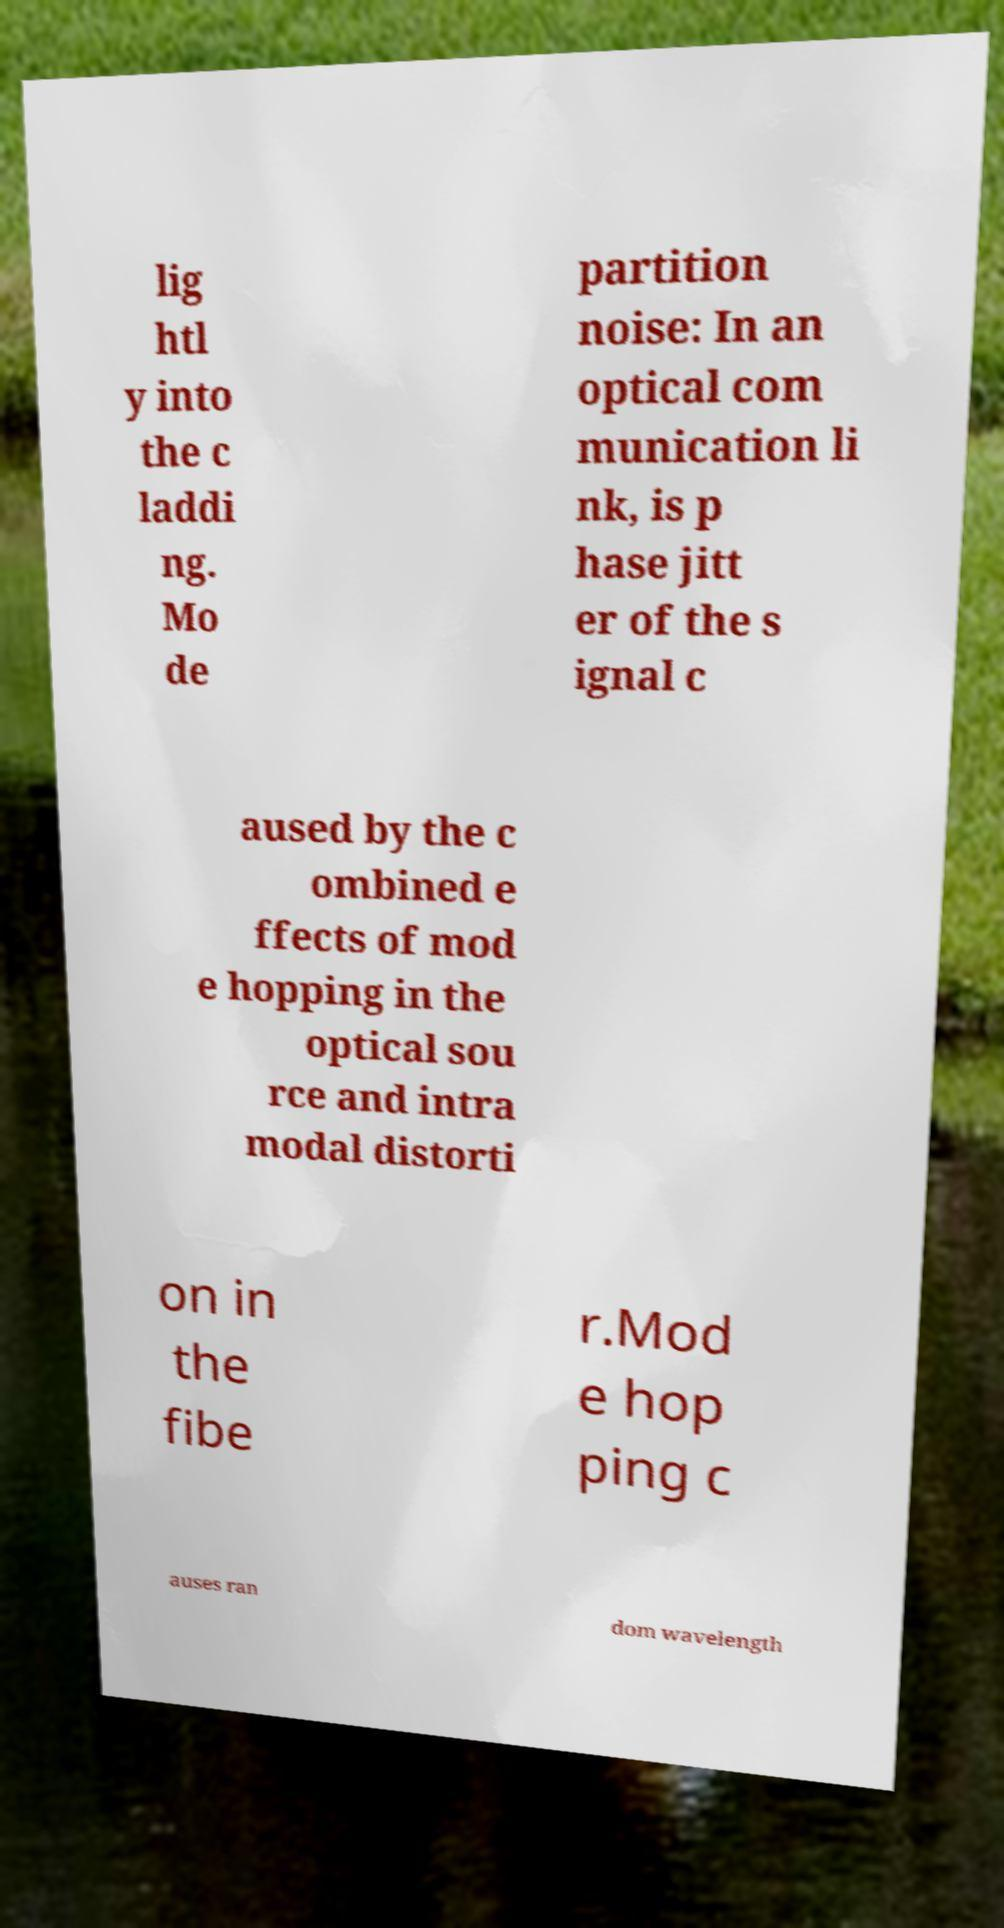Please read and relay the text visible in this image. What does it say? lig htl y into the c laddi ng. Mo de partition noise: In an optical com munication li nk, is p hase jitt er of the s ignal c aused by the c ombined e ffects of mod e hopping in the optical sou rce and intra modal distorti on in the fibe r.Mod e hop ping c auses ran dom wavelength 